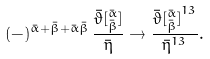<formula> <loc_0><loc_0><loc_500><loc_500>( - ) ^ { { \bar { \alpha } } + { \bar { \beta } } + \bar { \alpha } \bar { \beta } } \, \frac { { \bar { \vartheta } } [ ^ { \bar { \alpha } } _ { \bar { \beta } } ] } { \bar { \eta } } \rightarrow \frac { { \bar { \vartheta } [ ^ { \bar { \alpha } } _ { \bar { \beta } } ] } ^ { 1 3 } } { { \bar { \eta } } ^ { 1 3 } } .</formula> 